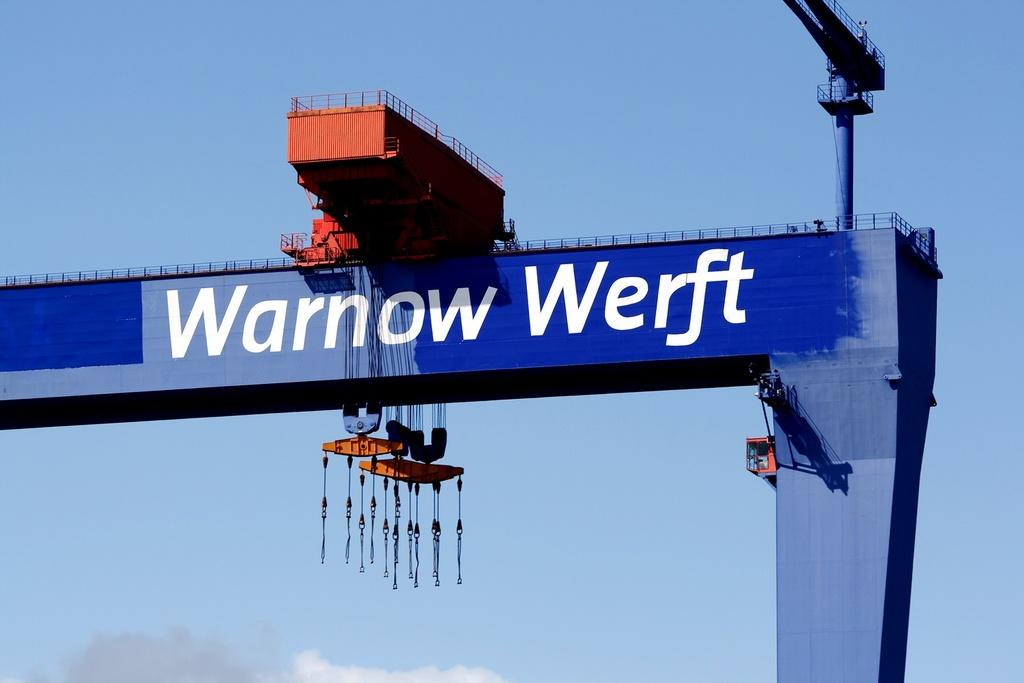Provide a one-sentence caption for the provided image. a crane with the words Warnow Werft written on it. 